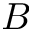<formula> <loc_0><loc_0><loc_500><loc_500>B</formula> 